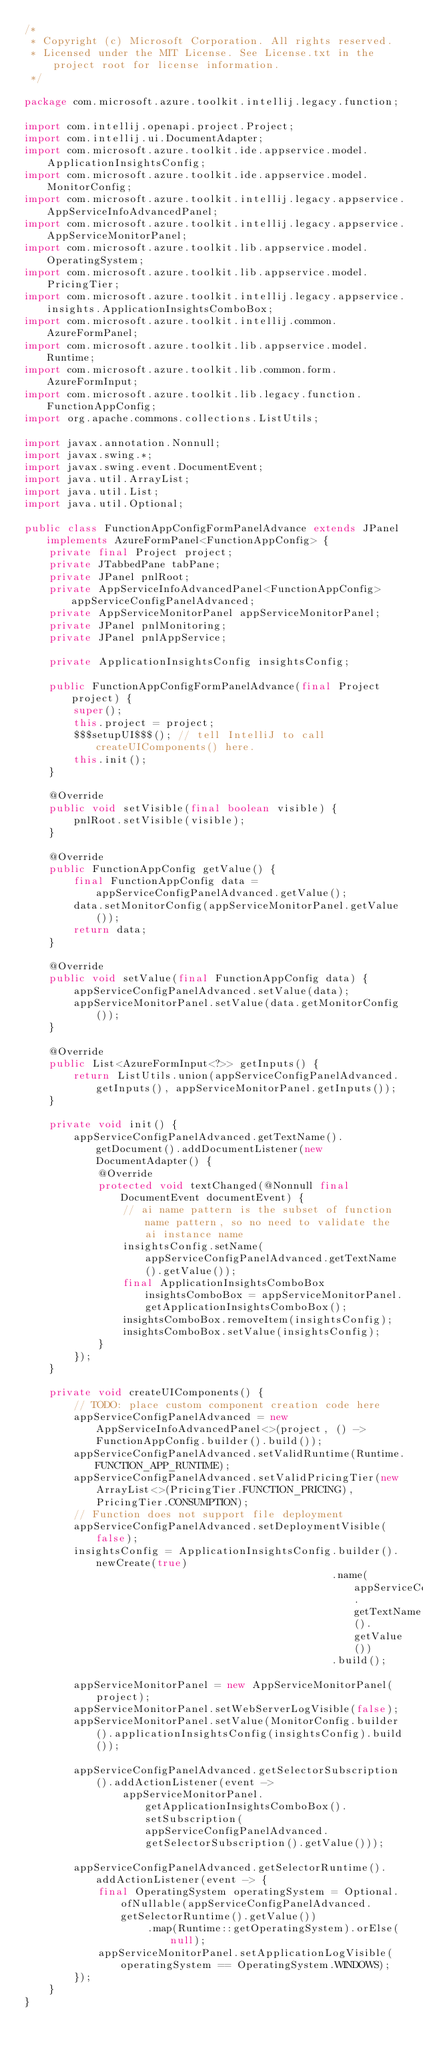Convert code to text. <code><loc_0><loc_0><loc_500><loc_500><_Java_>/*
 * Copyright (c) Microsoft Corporation. All rights reserved.
 * Licensed under the MIT License. See License.txt in the project root for license information.
 */

package com.microsoft.azure.toolkit.intellij.legacy.function;

import com.intellij.openapi.project.Project;
import com.intellij.ui.DocumentAdapter;
import com.microsoft.azure.toolkit.ide.appservice.model.ApplicationInsightsConfig;
import com.microsoft.azure.toolkit.ide.appservice.model.MonitorConfig;
import com.microsoft.azure.toolkit.intellij.legacy.appservice.AppServiceInfoAdvancedPanel;
import com.microsoft.azure.toolkit.intellij.legacy.appservice.AppServiceMonitorPanel;
import com.microsoft.azure.toolkit.lib.appservice.model.OperatingSystem;
import com.microsoft.azure.toolkit.lib.appservice.model.PricingTier;
import com.microsoft.azure.toolkit.intellij.legacy.appservice.insights.ApplicationInsightsComboBox;
import com.microsoft.azure.toolkit.intellij.common.AzureFormPanel;
import com.microsoft.azure.toolkit.lib.appservice.model.Runtime;
import com.microsoft.azure.toolkit.lib.common.form.AzureFormInput;
import com.microsoft.azure.toolkit.lib.legacy.function.FunctionAppConfig;
import org.apache.commons.collections.ListUtils;

import javax.annotation.Nonnull;
import javax.swing.*;
import javax.swing.event.DocumentEvent;
import java.util.ArrayList;
import java.util.List;
import java.util.Optional;

public class FunctionAppConfigFormPanelAdvance extends JPanel implements AzureFormPanel<FunctionAppConfig> {
    private final Project project;
    private JTabbedPane tabPane;
    private JPanel pnlRoot;
    private AppServiceInfoAdvancedPanel<FunctionAppConfig> appServiceConfigPanelAdvanced;
    private AppServiceMonitorPanel appServiceMonitorPanel;
    private JPanel pnlMonitoring;
    private JPanel pnlAppService;

    private ApplicationInsightsConfig insightsConfig;

    public FunctionAppConfigFormPanelAdvance(final Project project) {
        super();
        this.project = project;
        $$$setupUI$$$(); // tell IntelliJ to call createUIComponents() here.
        this.init();
    }

    @Override
    public void setVisible(final boolean visible) {
        pnlRoot.setVisible(visible);
    }

    @Override
    public FunctionAppConfig getValue() {
        final FunctionAppConfig data = appServiceConfigPanelAdvanced.getValue();
        data.setMonitorConfig(appServiceMonitorPanel.getValue());
        return data;
    }

    @Override
    public void setValue(final FunctionAppConfig data) {
        appServiceConfigPanelAdvanced.setValue(data);
        appServiceMonitorPanel.setValue(data.getMonitorConfig());
    }

    @Override
    public List<AzureFormInput<?>> getInputs() {
        return ListUtils.union(appServiceConfigPanelAdvanced.getInputs(), appServiceMonitorPanel.getInputs());
    }

    private void init() {
        appServiceConfigPanelAdvanced.getTextName().getDocument().addDocumentListener(new DocumentAdapter() {
            @Override
            protected void textChanged(@Nonnull final DocumentEvent documentEvent) {
                // ai name pattern is the subset of function name pattern, so no need to validate the ai instance name
                insightsConfig.setName(appServiceConfigPanelAdvanced.getTextName().getValue());
                final ApplicationInsightsComboBox insightsComboBox = appServiceMonitorPanel.getApplicationInsightsComboBox();
                insightsComboBox.removeItem(insightsConfig);
                insightsComboBox.setValue(insightsConfig);
            }
        });
    }

    private void createUIComponents() {
        // TODO: place custom component creation code here
        appServiceConfigPanelAdvanced = new AppServiceInfoAdvancedPanel<>(project, () -> FunctionAppConfig.builder().build());
        appServiceConfigPanelAdvanced.setValidRuntime(Runtime.FUNCTION_APP_RUNTIME);
        appServiceConfigPanelAdvanced.setValidPricingTier(new ArrayList<>(PricingTier.FUNCTION_PRICING), PricingTier.CONSUMPTION);
        // Function does not support file deployment
        appServiceConfigPanelAdvanced.setDeploymentVisible(false);
        insightsConfig = ApplicationInsightsConfig.builder().newCreate(true)
                                                  .name(appServiceConfigPanelAdvanced.getTextName().getValue())
                                                  .build();

        appServiceMonitorPanel = new AppServiceMonitorPanel(project);
        appServiceMonitorPanel.setWebServerLogVisible(false);
        appServiceMonitorPanel.setValue(MonitorConfig.builder().applicationInsightsConfig(insightsConfig).build());

        appServiceConfigPanelAdvanced.getSelectorSubscription().addActionListener(event ->
                appServiceMonitorPanel.getApplicationInsightsComboBox().setSubscription(appServiceConfigPanelAdvanced.getSelectorSubscription().getValue()));

        appServiceConfigPanelAdvanced.getSelectorRuntime().addActionListener(event -> {
            final OperatingSystem operatingSystem = Optional.ofNullable(appServiceConfigPanelAdvanced.getSelectorRuntime().getValue())
                    .map(Runtime::getOperatingSystem).orElse(null);
            appServiceMonitorPanel.setApplicationLogVisible(operatingSystem == OperatingSystem.WINDOWS);
        });
    }
}
</code> 